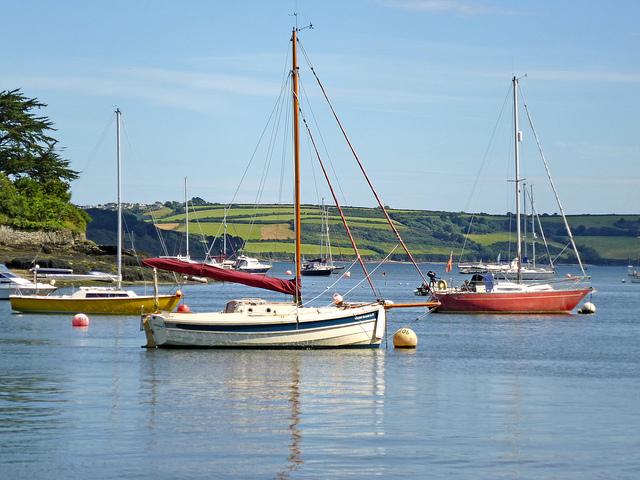What are the round floating objects?
Give a very brief answer. Buoys. How many boats are on the water?
Quick response, please. 7. Are there any fields in the background?
Concise answer only. Yes. Is it foggy?
Write a very short answer. No. 